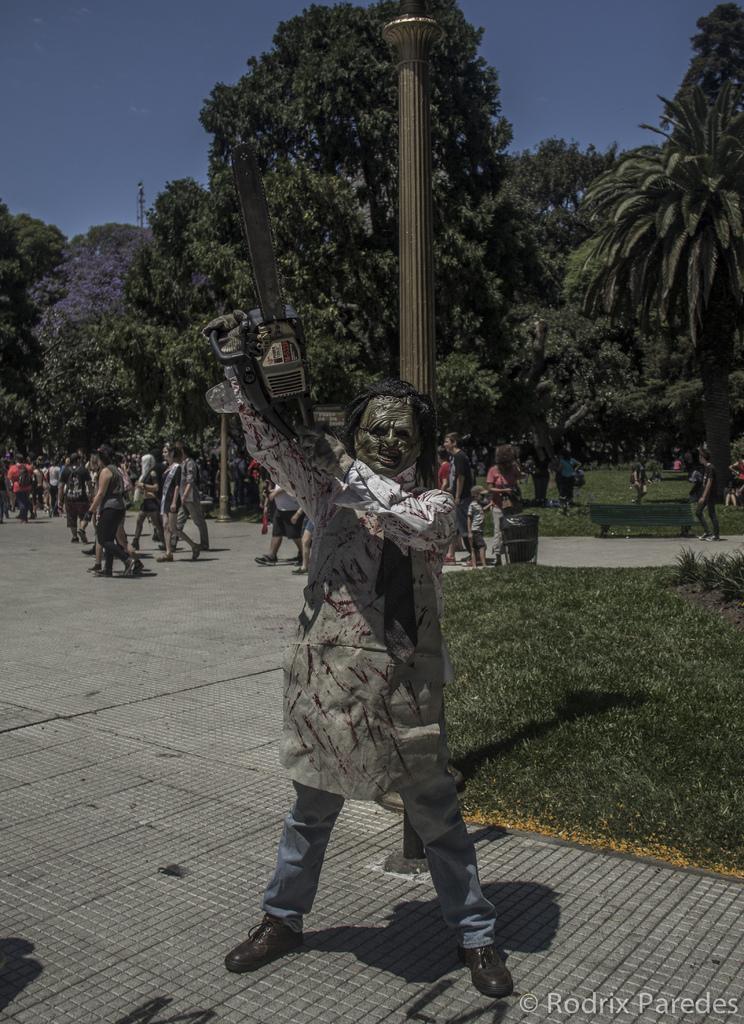Describe this image in one or two sentences. In this image I can see number of people are standing and in the front I can see one person is wearing a costume. I can also see this person is holding a chainsaw. In the background I can see an open grass ground, number of trees, a pole, the sky and on the bottom side of this image I can see a watermark. 